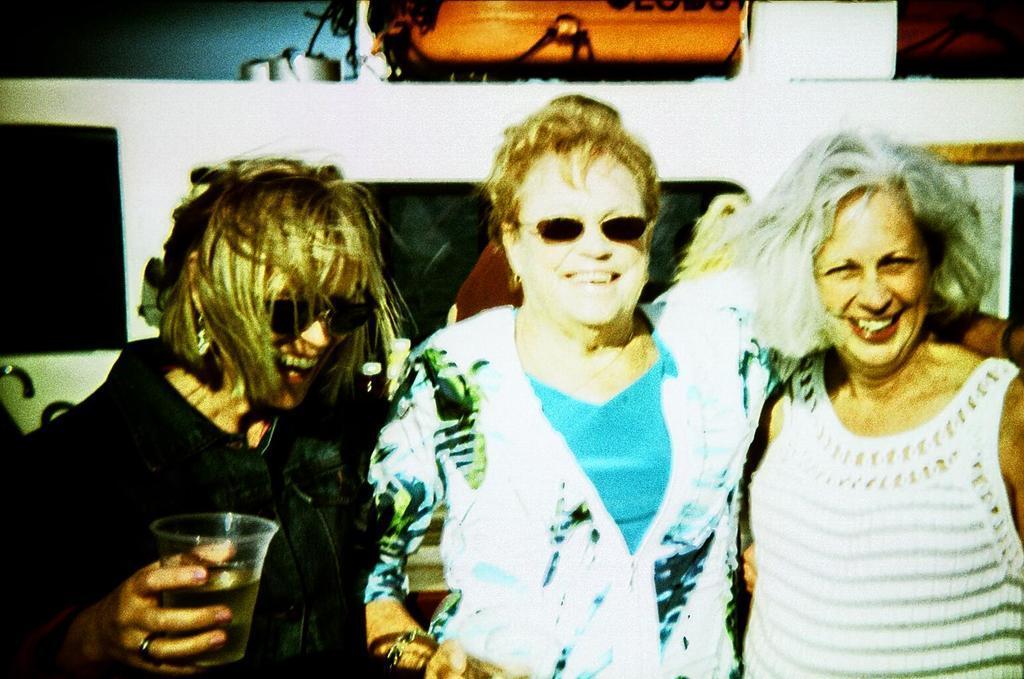Could you give a brief overview of what you see in this image? In this image I can see three people with different color dresses. I can see two people with the goggles and one person is holding the glass. In the background there might be photo frames and borders to the wall. 